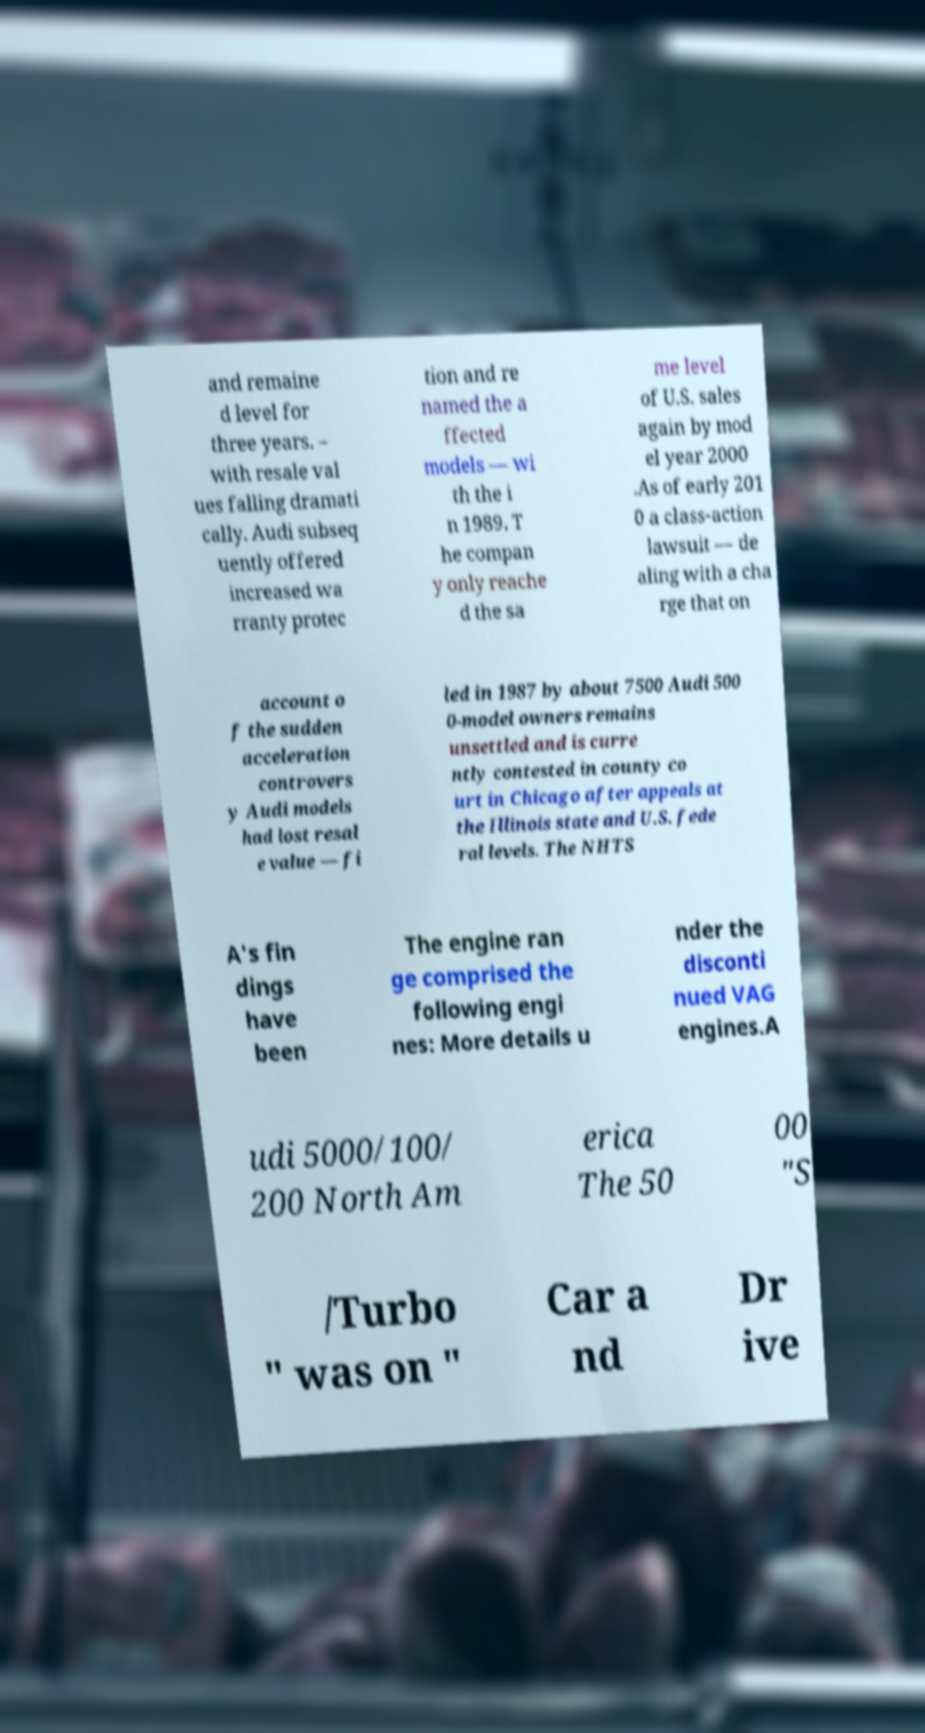There's text embedded in this image that I need extracted. Can you transcribe it verbatim? and remaine d level for three years. – with resale val ues falling dramati cally. Audi subseq uently offered increased wa rranty protec tion and re named the a ffected models — wi th the i n 1989. T he compan y only reache d the sa me level of U.S. sales again by mod el year 2000 .As of early 201 0 a class-action lawsuit — de aling with a cha rge that on account o f the sudden acceleration controvers y Audi models had lost resal e value — fi led in 1987 by about 7500 Audi 500 0-model owners remains unsettled and is curre ntly contested in county co urt in Chicago after appeals at the Illinois state and U.S. fede ral levels. The NHTS A's fin dings have been The engine ran ge comprised the following engi nes: More details u nder the disconti nued VAG engines.A udi 5000/100/ 200 North Am erica The 50 00 "S /Turbo " was on " Car a nd Dr ive 